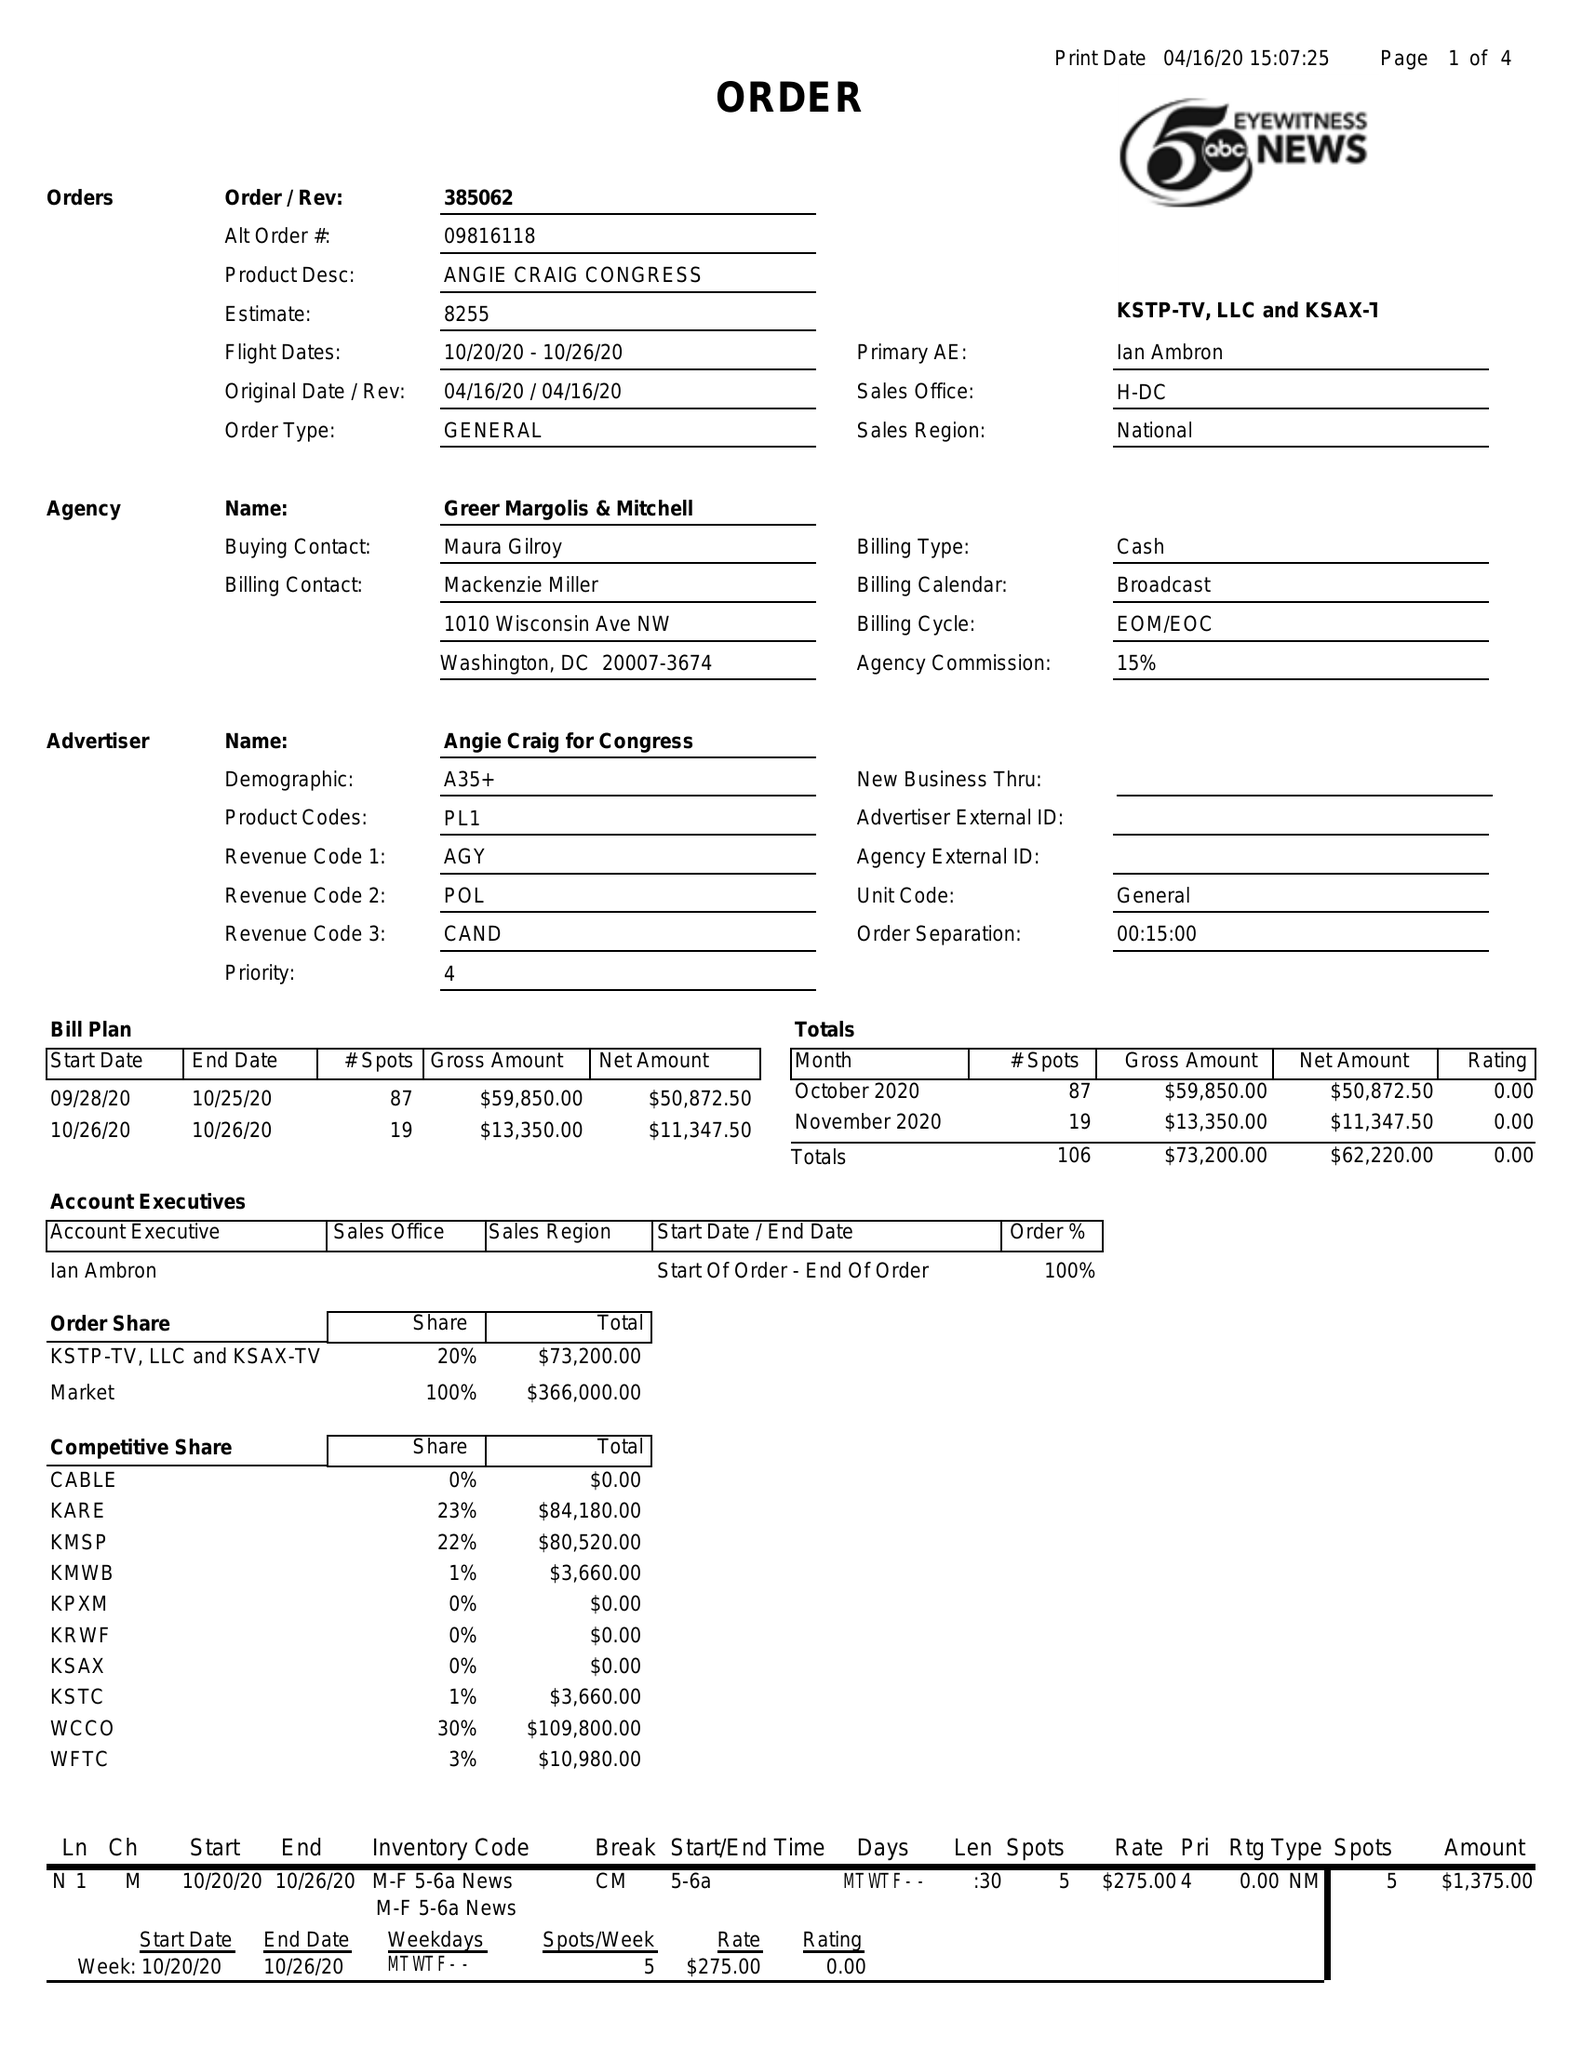What is the value for the contract_num?
Answer the question using a single word or phrase. 385062 